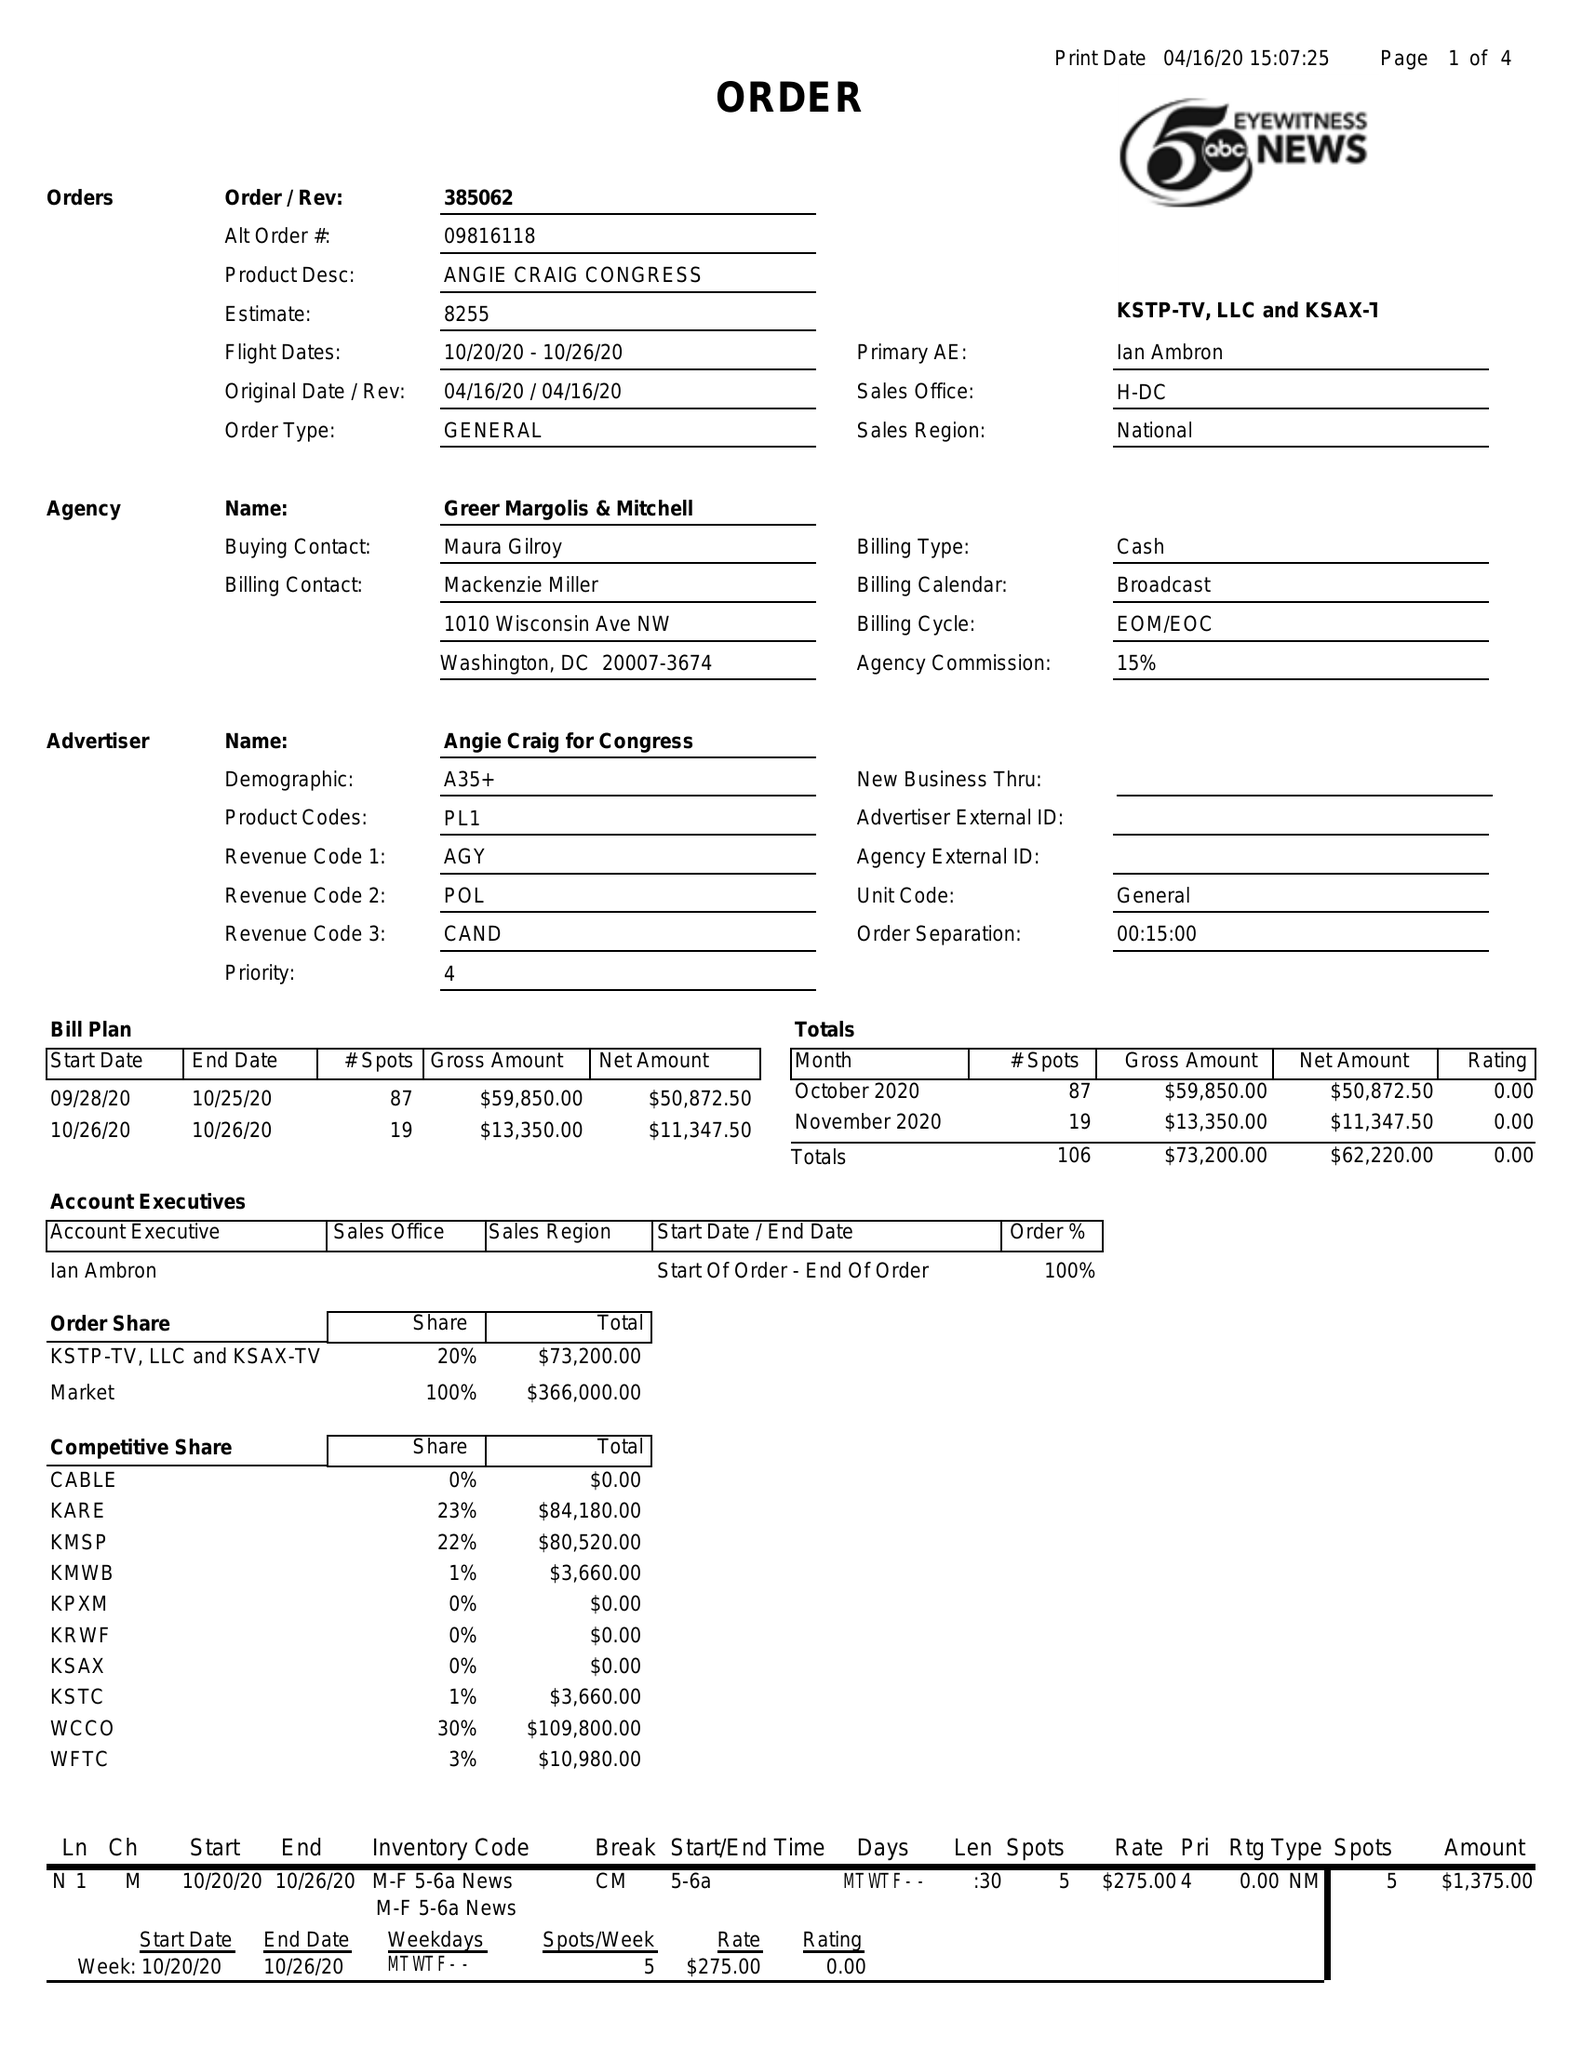What is the value for the contract_num?
Answer the question using a single word or phrase. 385062 